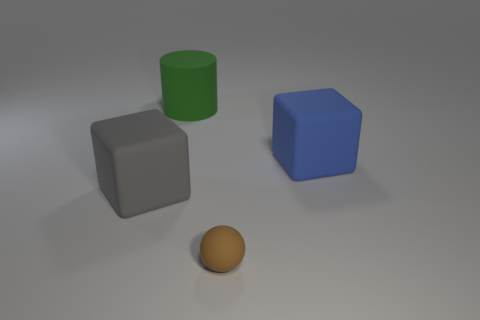There is a brown matte ball; does it have the same size as the block to the left of the large green rubber cylinder? The brown matte ball appears to be smaller in size when compared to the gray block positioned to the left of the large green rubber cylinder, emphasizing their distinctive dimensions. 